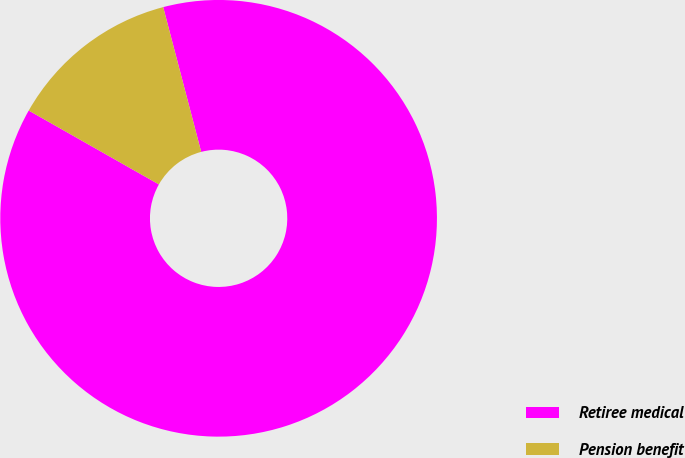Convert chart. <chart><loc_0><loc_0><loc_500><loc_500><pie_chart><fcel>Retiree medical<fcel>Pension benefit<nl><fcel>87.3%<fcel>12.7%<nl></chart> 